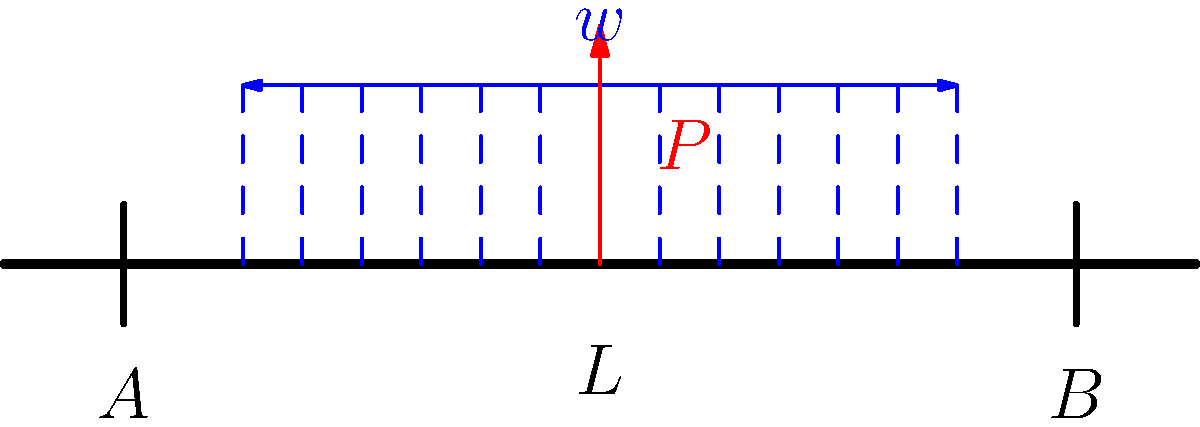In a scene reminiscent of Paresh Rawal's comedic genius, imagine a beam supporting both a distributed load $w$ and a point load $P$ at its center. The beam of length $L$ is simply supported at both ends. Determine the maximum bending moment $M_{max}$ in terms of $w$, $P$, and $L$. Assume the distributed load is uniform across the entire length of the beam. Let's approach this step-by-step, with the precision of Paresh Rawal delivering his punchlines:

1) First, we need to determine the reactions at the supports A and B. Due to symmetry, $R_A = R_B = R$.

2) For equilibrium: $2R = wL + P$
   Therefore, $R = \frac{wL + P}{2}$

3) Now, let's consider the bending moment at the center of the beam (where it will be maximum due to symmetry):

   $M_{max} = RA \cdot \frac{L}{2} - w \cdot \frac{L}{2} \cdot \frac{L}{4} - P \cdot 0$

4) Substituting the value of $R$:

   $M_{max} = \frac{wL + P}{2} \cdot \frac{L}{2} - w \cdot \frac{L}{2} \cdot \frac{L}{4}$

5) Simplifying:

   $M_{max} = \frac{wL^2}{4} + \frac{PL}{4} - \frac{wL^2}{8}$

6) Further simplifying:

   $M_{max} = \frac{wL^2}{8} + \frac{PL}{4}$

This final expression gives us the maximum bending moment in terms of $w$, $P$, and $L$.
Answer: $M_{max} = \frac{wL^2}{8} + \frac{PL}{4}$ 